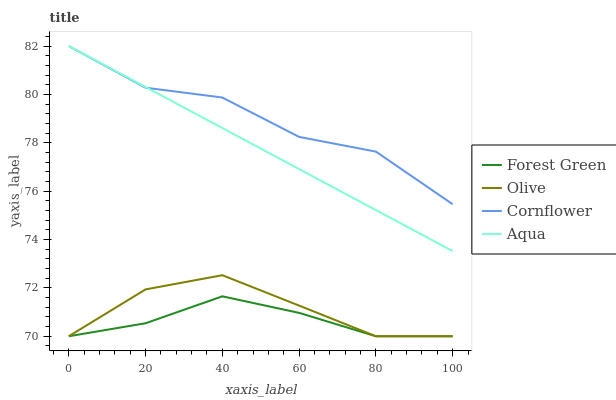Does Forest Green have the minimum area under the curve?
Answer yes or no. Yes. Does Cornflower have the maximum area under the curve?
Answer yes or no. Yes. Does Cornflower have the minimum area under the curve?
Answer yes or no. No. Does Forest Green have the maximum area under the curve?
Answer yes or no. No. Is Aqua the smoothest?
Answer yes or no. Yes. Is Cornflower the roughest?
Answer yes or no. Yes. Is Forest Green the smoothest?
Answer yes or no. No. Is Forest Green the roughest?
Answer yes or no. No. Does Olive have the lowest value?
Answer yes or no. Yes. Does Cornflower have the lowest value?
Answer yes or no. No. Does Aqua have the highest value?
Answer yes or no. Yes. Does Cornflower have the highest value?
Answer yes or no. No. Is Forest Green less than Aqua?
Answer yes or no. Yes. Is Aqua greater than Olive?
Answer yes or no. Yes. Does Olive intersect Forest Green?
Answer yes or no. Yes. Is Olive less than Forest Green?
Answer yes or no. No. Is Olive greater than Forest Green?
Answer yes or no. No. Does Forest Green intersect Aqua?
Answer yes or no. No. 